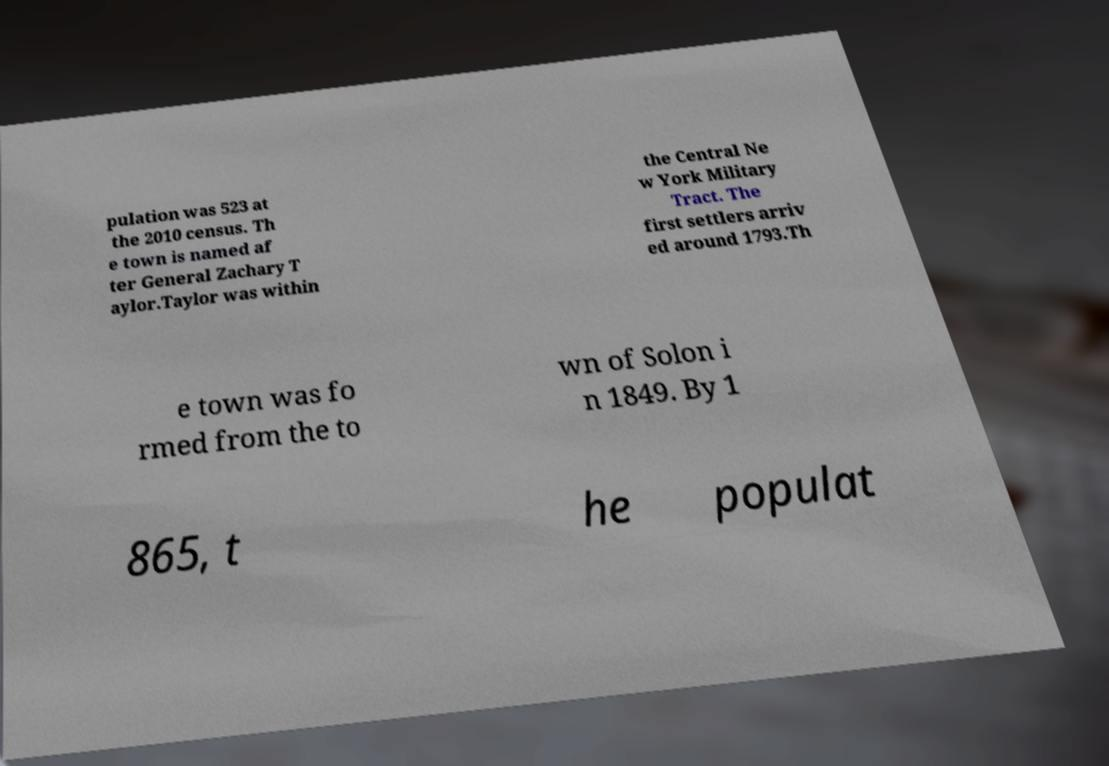Can you accurately transcribe the text from the provided image for me? pulation was 523 at the 2010 census. Th e town is named af ter General Zachary T aylor.Taylor was within the Central Ne w York Military Tract. The first settlers arriv ed around 1793.Th e town was fo rmed from the to wn of Solon i n 1849. By 1 865, t he populat 